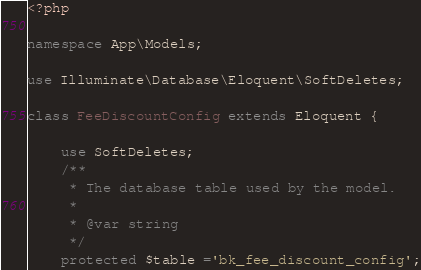Convert code to text. <code><loc_0><loc_0><loc_500><loc_500><_PHP_><?php

namespace App\Models;

use Illuminate\Database\Eloquent\SoftDeletes;

class FeeDiscountConfig extends Eloquent {

	use SoftDeletes;
	/**
	 * The database table used by the model.
	 *
	 * @var string
	 */
	protected $table ='bk_fee_discount_config';</code> 